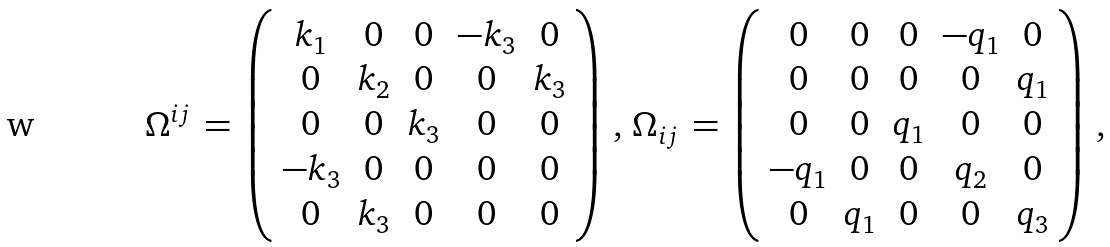<formula> <loc_0><loc_0><loc_500><loc_500>\Omega ^ { i j } \, = \, \left ( \begin{array} { c c c c c } k _ { 1 } & 0 & 0 & - k _ { 3 } & 0 \\ 0 & k _ { 2 } & 0 & 0 & k _ { 3 } \\ 0 & 0 & k _ { 3 } & 0 & 0 \\ - k _ { 3 } & 0 & 0 & 0 & 0 \\ 0 & k _ { 3 } & 0 & 0 & 0 \end{array} \right ) \, , \, \Omega _ { i j } \, = \, \left ( \begin{array} { c c c c c } 0 & 0 & 0 & - q _ { 1 } & 0 \\ 0 & 0 & 0 & 0 & q _ { 1 } \\ 0 & 0 & q _ { 1 } & 0 & 0 \\ - q _ { 1 } & 0 & 0 & q _ { 2 } & 0 \\ 0 & q _ { 1 } & 0 & 0 & q _ { 3 } \end{array} \right ) \, ,</formula> 